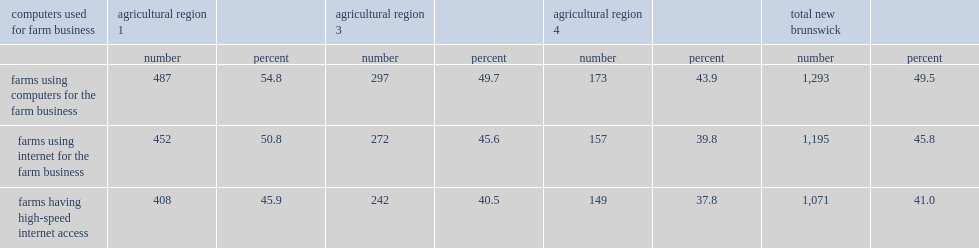Can you parse all the data within this table? {'header': ['computers used for farm business', 'agricultural region 1', '', 'agricultural region 3', '', 'agricultural region 4', '', 'total new brunswick', ''], 'rows': [['', 'number', 'percent', 'number', 'percent', 'number', 'percent', 'number', 'percent'], ['farms using computers for the farm business', '487', '54.8', '297', '49.7', '173', '43.9', '1,293', '49.5'], ['farms using internet for the farm business', '452', '50.8', '272', '45.6', '157', '39.8', '1,195', '45.8'], ['farms having high-speed internet access', '408', '45.9', '242', '40.5', '149', '37.8', '1,071', '41.0']]} What fraction of farms in new brunswick and its agriculturl regions used computers for farms operations? 49.5. Which agricultural region was less likely to use computers or the internet for farms operations compared with all farms in new brunswick? Agricultural region 4. Which agricultural region had fewer high speed internet access, compared with all farms in new brunswick? Agricultural region 4. Which agricultural region farms were more likely to use computers or the internet for famrs operations, compared with all farms in new brunswick? Agricultural region 1. Which agricultural region farms were more likely to use high-speed internet access, compared with all farms in new brunswick? Farms having high-speed internet access. 